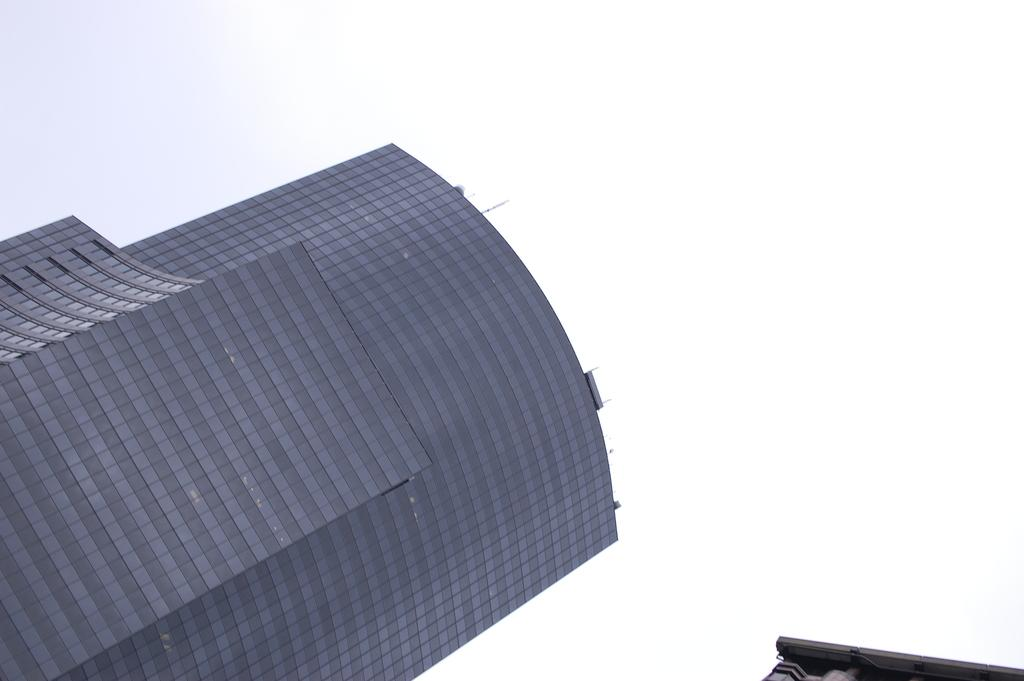What type of structure can be seen in the image? There is a building in the image. What part of the natural environment is visible in the image? The sky is visible in the image. What type of death can be seen in the image? There is no death present in the image; it features a building and the sky. How does the building stop people from entering in the image? The image does not show the building stopping people from entering, nor does it depict any people attempting to enter. 